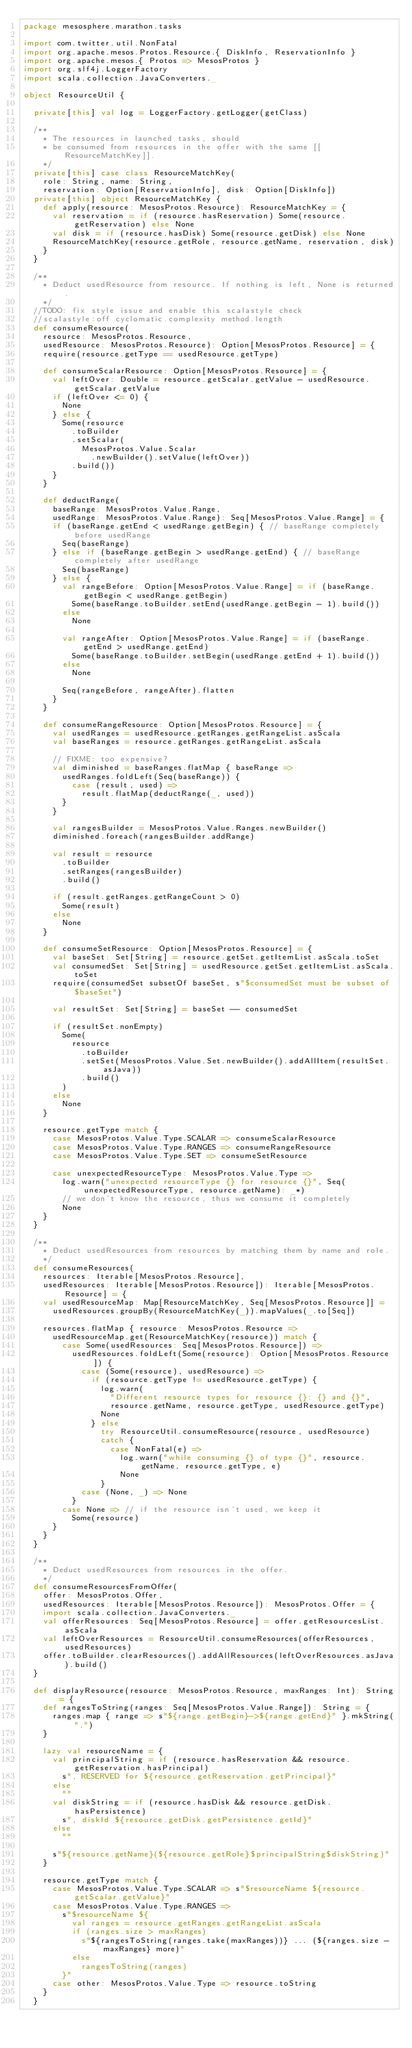Convert code to text. <code><loc_0><loc_0><loc_500><loc_500><_Scala_>package mesosphere.marathon.tasks

import com.twitter.util.NonFatal
import org.apache.mesos.Protos.Resource.{ DiskInfo, ReservationInfo }
import org.apache.mesos.{ Protos => MesosProtos }
import org.slf4j.LoggerFactory
import scala.collection.JavaConverters._

object ResourceUtil {

  private[this] val log = LoggerFactory.getLogger(getClass)

  /**
    * The resources in launched tasks, should
    * be consumed from resources in the offer with the same [[ResourceMatchKey]].
    */
  private[this] case class ResourceMatchKey(
    role: String, name: String,
    reservation: Option[ReservationInfo], disk: Option[DiskInfo])
  private[this] object ResourceMatchKey {
    def apply(resource: MesosProtos.Resource): ResourceMatchKey = {
      val reservation = if (resource.hasReservation) Some(resource.getReservation) else None
      val disk = if (resource.hasDisk) Some(resource.getDisk) else None
      ResourceMatchKey(resource.getRole, resource.getName, reservation, disk)
    }
  }

  /**
    * Deduct usedResource from resource. If nothing is left, None is returned.
    */
  //TODO: fix style issue and enable this scalastyle check
  //scalastyle:off cyclomatic.complexity method.length
  def consumeResource(
    resource: MesosProtos.Resource,
    usedResource: MesosProtos.Resource): Option[MesosProtos.Resource] = {
    require(resource.getType == usedResource.getType)

    def consumeScalarResource: Option[MesosProtos.Resource] = {
      val leftOver: Double = resource.getScalar.getValue - usedResource.getScalar.getValue
      if (leftOver <= 0) {
        None
      } else {
        Some(resource
          .toBuilder
          .setScalar(
            MesosProtos.Value.Scalar
              .newBuilder().setValue(leftOver))
          .build())
      }
    }

    def deductRange(
      baseRange: MesosProtos.Value.Range,
      usedRange: MesosProtos.Value.Range): Seq[MesosProtos.Value.Range] = {
      if (baseRange.getEnd < usedRange.getBegin) { // baseRange completely before usedRange
        Seq(baseRange)
      } else if (baseRange.getBegin > usedRange.getEnd) { // baseRange completely after usedRange
        Seq(baseRange)
      } else {
        val rangeBefore: Option[MesosProtos.Value.Range] = if (baseRange.getBegin < usedRange.getBegin)
          Some(baseRange.toBuilder.setEnd(usedRange.getBegin - 1).build())
        else
          None

        val rangeAfter: Option[MesosProtos.Value.Range] = if (baseRange.getEnd > usedRange.getEnd)
          Some(baseRange.toBuilder.setBegin(usedRange.getEnd + 1).build())
        else
          None

        Seq(rangeBefore, rangeAfter).flatten
      }
    }

    def consumeRangeResource: Option[MesosProtos.Resource] = {
      val usedRanges = usedResource.getRanges.getRangeList.asScala
      val baseRanges = resource.getRanges.getRangeList.asScala

      // FIXME: too expensive?
      val diminished = baseRanges.flatMap { baseRange =>
        usedRanges.foldLeft(Seq(baseRange)) {
          case (result, used) =>
            result.flatMap(deductRange(_, used))
        }
      }

      val rangesBuilder = MesosProtos.Value.Ranges.newBuilder()
      diminished.foreach(rangesBuilder.addRange)

      val result = resource
        .toBuilder
        .setRanges(rangesBuilder)
        .build()

      if (result.getRanges.getRangeCount > 0)
        Some(result)
      else
        None
    }

    def consumeSetResource: Option[MesosProtos.Resource] = {
      val baseSet: Set[String] = resource.getSet.getItemList.asScala.toSet
      val consumedSet: Set[String] = usedResource.getSet.getItemList.asScala.toSet
      require(consumedSet subsetOf baseSet, s"$consumedSet must be subset of $baseSet")

      val resultSet: Set[String] = baseSet -- consumedSet

      if (resultSet.nonEmpty)
        Some(
          resource
            .toBuilder
            .setSet(MesosProtos.Value.Set.newBuilder().addAllItem(resultSet.asJava))
            .build()
        )
      else
        None
    }

    resource.getType match {
      case MesosProtos.Value.Type.SCALAR => consumeScalarResource
      case MesosProtos.Value.Type.RANGES => consumeRangeResource
      case MesosProtos.Value.Type.SET => consumeSetResource

      case unexpectedResourceType: MesosProtos.Value.Type =>
        log.warn("unexpected resourceType {} for resource {}", Seq(unexpectedResourceType, resource.getName): _*)
        // we don't know the resource, thus we consume it completely
        None
    }
  }

  /**
    * Deduct usedResources from resources by matching them by name and role.
    */
  def consumeResources(
    resources: Iterable[MesosProtos.Resource],
    usedResources: Iterable[MesosProtos.Resource]): Iterable[MesosProtos.Resource] = {
    val usedResourceMap: Map[ResourceMatchKey, Seq[MesosProtos.Resource]] =
      usedResources.groupBy(ResourceMatchKey(_)).mapValues(_.to[Seq])

    resources.flatMap { resource: MesosProtos.Resource =>
      usedResourceMap.get(ResourceMatchKey(resource)) match {
        case Some(usedResources: Seq[MesosProtos.Resource]) =>
          usedResources.foldLeft(Some(resource): Option[MesosProtos.Resource]) {
            case (Some(resource), usedResource) =>
              if (resource.getType != usedResource.getType) {
                log.warn(
                  "Different resource types for resource {}: {} and {}",
                  resource.getName, resource.getType, usedResource.getType)
                None
              } else
                try ResourceUtil.consumeResource(resource, usedResource)
                catch {
                  case NonFatal(e) =>
                    log.warn("while consuming {} of type {}", resource.getName, resource.getType, e)
                    None
                }
            case (None, _) => None
          }
        case None => // if the resource isn't used, we keep it
          Some(resource)
      }
    }
  }

  /**
    * Deduct usedResources from resources in the offer.
    */
  def consumeResourcesFromOffer(
    offer: MesosProtos.Offer,
    usedResources: Iterable[MesosProtos.Resource]): MesosProtos.Offer = {
    import scala.collection.JavaConverters._
    val offerResources: Seq[MesosProtos.Resource] = offer.getResourcesList.asScala
    val leftOverResources = ResourceUtil.consumeResources(offerResources, usedResources)
    offer.toBuilder.clearResources().addAllResources(leftOverResources.asJava).build()
  }

  def displayResource(resource: MesosProtos.Resource, maxRanges: Int): String = {
    def rangesToString(ranges: Seq[MesosProtos.Value.Range]): String = {
      ranges.map { range => s"${range.getBegin}->${range.getEnd}" }.mkString(",")
    }

    lazy val resourceName = {
      val principalString = if (resource.hasReservation && resource.getReservation.hasPrincipal)
        s", RESERVED for ${resource.getReservation.getPrincipal}"
      else
        ""
      val diskString = if (resource.hasDisk && resource.getDisk.hasPersistence)
        s", diskId ${resource.getDisk.getPersistence.getId}"
      else
        ""

      s"${resource.getName}(${resource.getRole}$principalString$diskString)"
    }

    resource.getType match {
      case MesosProtos.Value.Type.SCALAR => s"$resourceName ${resource.getScalar.getValue}"
      case MesosProtos.Value.Type.RANGES =>
        s"$resourceName ${
          val ranges = resource.getRanges.getRangeList.asScala
          if (ranges.size > maxRanges)
            s"${rangesToString(ranges.take(maxRanges))} ... (${ranges.size - maxRanges} more)"
          else
            rangesToString(ranges)
        }"
      case other: MesosProtos.Value.Type => resource.toString
    }
  }
</code> 